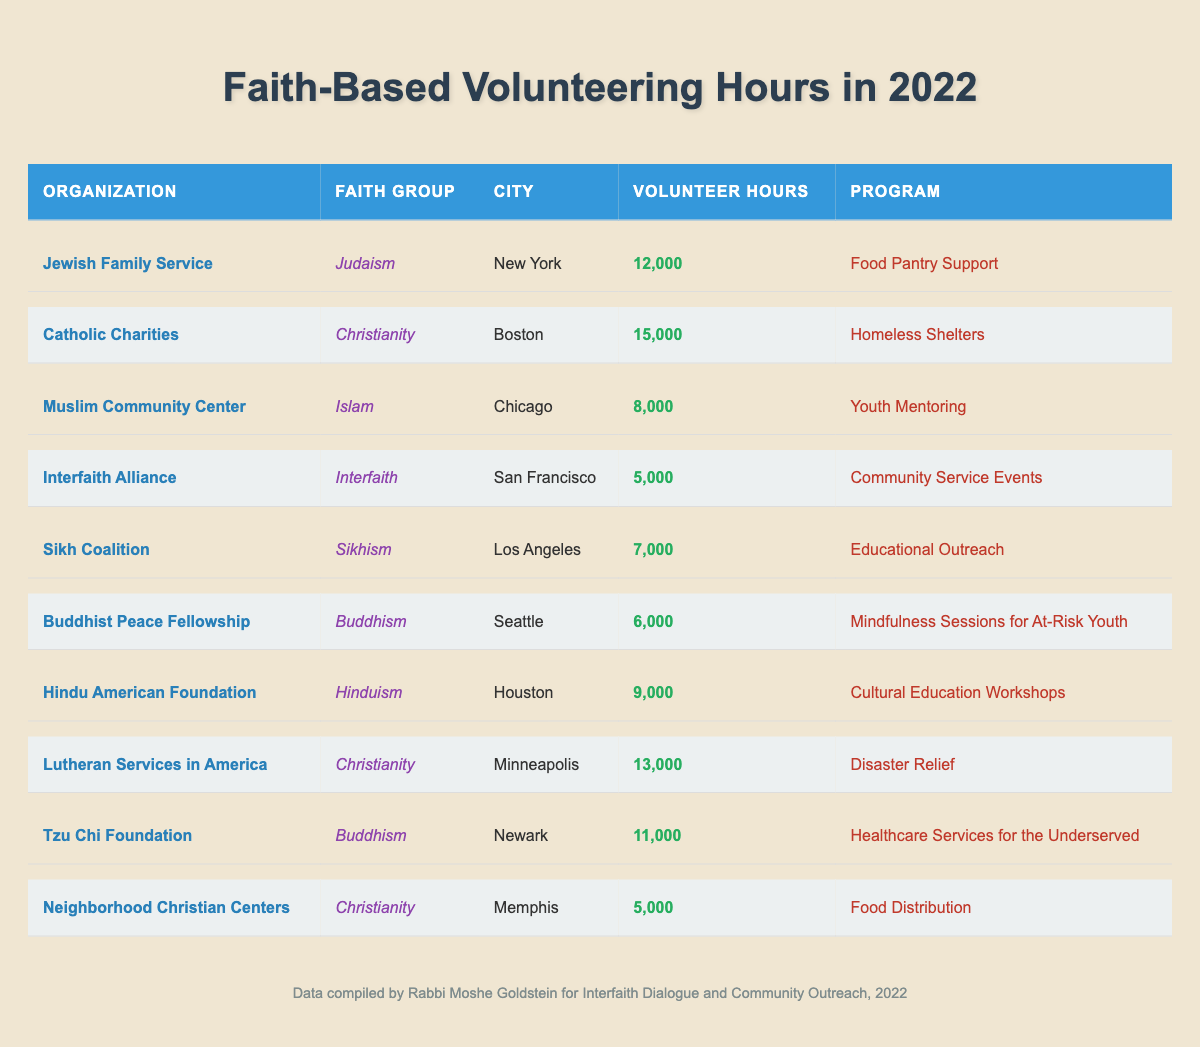What organization logged the highest volunteering hours? To find the organization with the highest volunteering hours, I compare all the values in the "Volunteer Hours" column. Catholic Charities has the highest at 15,000 hours.
Answer: Catholic Charities How many volunteer hours were logged by religious organizations in Houston? The only organization from Houston is the Hindu American Foundation, which logged 9,000 volunteer hours.
Answer: 9,000 Which faith group has the least volunteering hours recorded? I check the "Volunteer Hours" column for each faith group. Interfaith Alliance has the least with 5,000 hours.
Answer: Interfaith What is the total number of volunteer hours for organizations affiliated with Christianity? I add the volunteer hours for all the Christian organizations: Catholic Charities (15,000) + Lutheran Services in America (13,000) + Neighborhood Christian Centers (5,000) = 33,000 hours.
Answer: 33,000 Did any organization from Chicago log more than 10,000 volunteer hours? The only organization from Chicago is the Muslim Community Center, which logged 8,000 hours, so it did not exceed 10,000 hours.
Answer: No What is the average volunteering hours logged by organizations affiliated with Buddhism? The two organizations are Buddhist Peace Fellowship (6,000) and Tzu Chi Foundation (11,000). The average is (6,000 + 11,000) / 2 = 8,500 hours.
Answer: 8,500 Which city had the second highest number of volunteer hours logged by faith-based organizations? The total volunteer hours for each city are: New York (12,000), Boston (15,000), Chicago (8,000), San Francisco (5,000), Los Angeles (7,000), Seattle (6,000), and Houston (9,000). Boston has the highest (15,000), and New York is second (12,000).
Answer: New York Were more than 20,000 hours logged by a single city in total? I sum the hours for each city: New York (12,000) + Boston (15,000) + Chicago (8,000) + San Francisco (5,000) + Los Angeles (7,000) + Seattle (6,000) + Houston (9,000) = 62,000 hoursTotal is 62,000 hours, which is more than 20,000.
Answer: Yes How many volunteer hours did the Sikh Coalition log compared to the Buddhist Peace Fellowship? Sikh Coalition logged 7,000 hours, while Buddhist Peace Fellowship logged 6,000 hours. Therefore, Sikh Coalition logged 1,000 hours more.
Answer: 1,000 Which programs are focused on youth-related activities? The organizations with youth-related programs are Muslim Community Center (Youth Mentoring) and Buddhist Peace Fellowship (Mindfulness Sessions for At-Risk Youth). Both programs cater to youth.
Answer: Muslim Community Center, Buddhist Peace Fellowship 